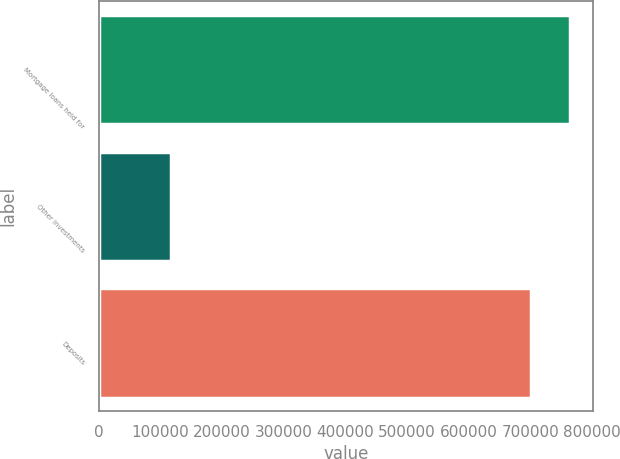<chart> <loc_0><loc_0><loc_500><loc_500><bar_chart><fcel>Mortgage loans held for<fcel>Other investments<fcel>Deposits<nl><fcel>763611<fcel>117350<fcel>700707<nl></chart> 